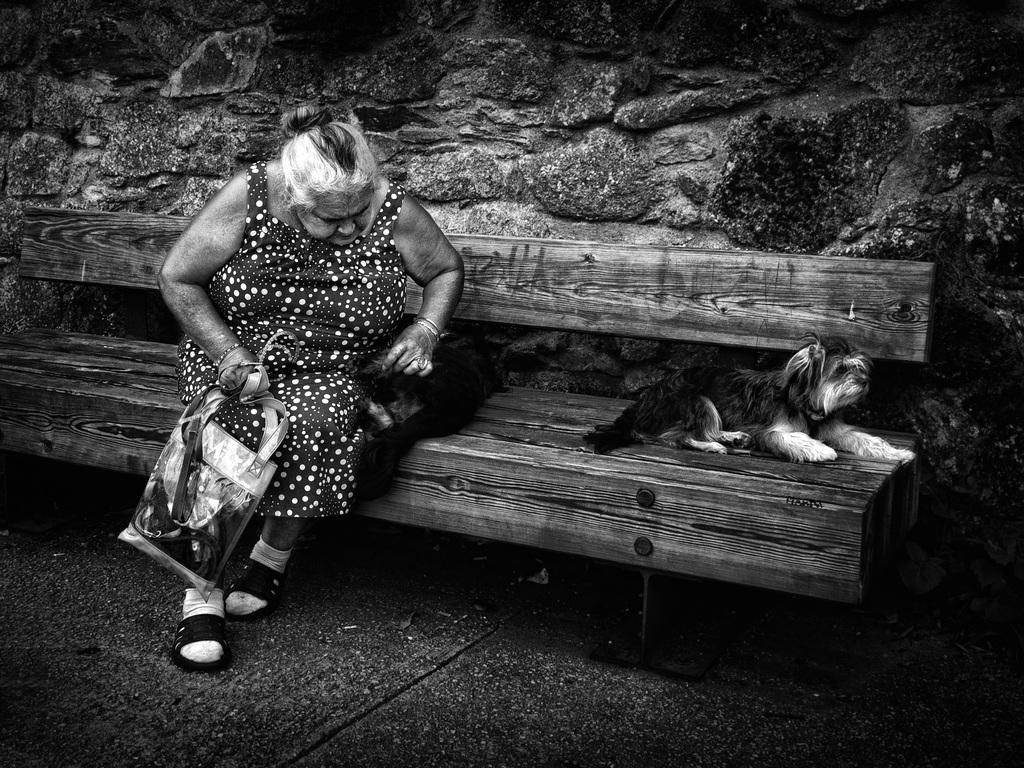What is the lady in the image wearing? The lady is wearing a dot dress. What is the lady holding in the image? The lady is holding a bag. What animal is present in the image? There is a cat in the image. What are the lady and the cat doing in the image? The lady and the cat are sitting on a bench. What other animal is present on the bench? There is a dog sitting on the bench. What can be seen in the background of the image? There is a rock wall in the background of the image. What type of fuel is the lady using to power her dress in the image? There is no indication in the image that the lady's dress is powered by any type of fuel. 